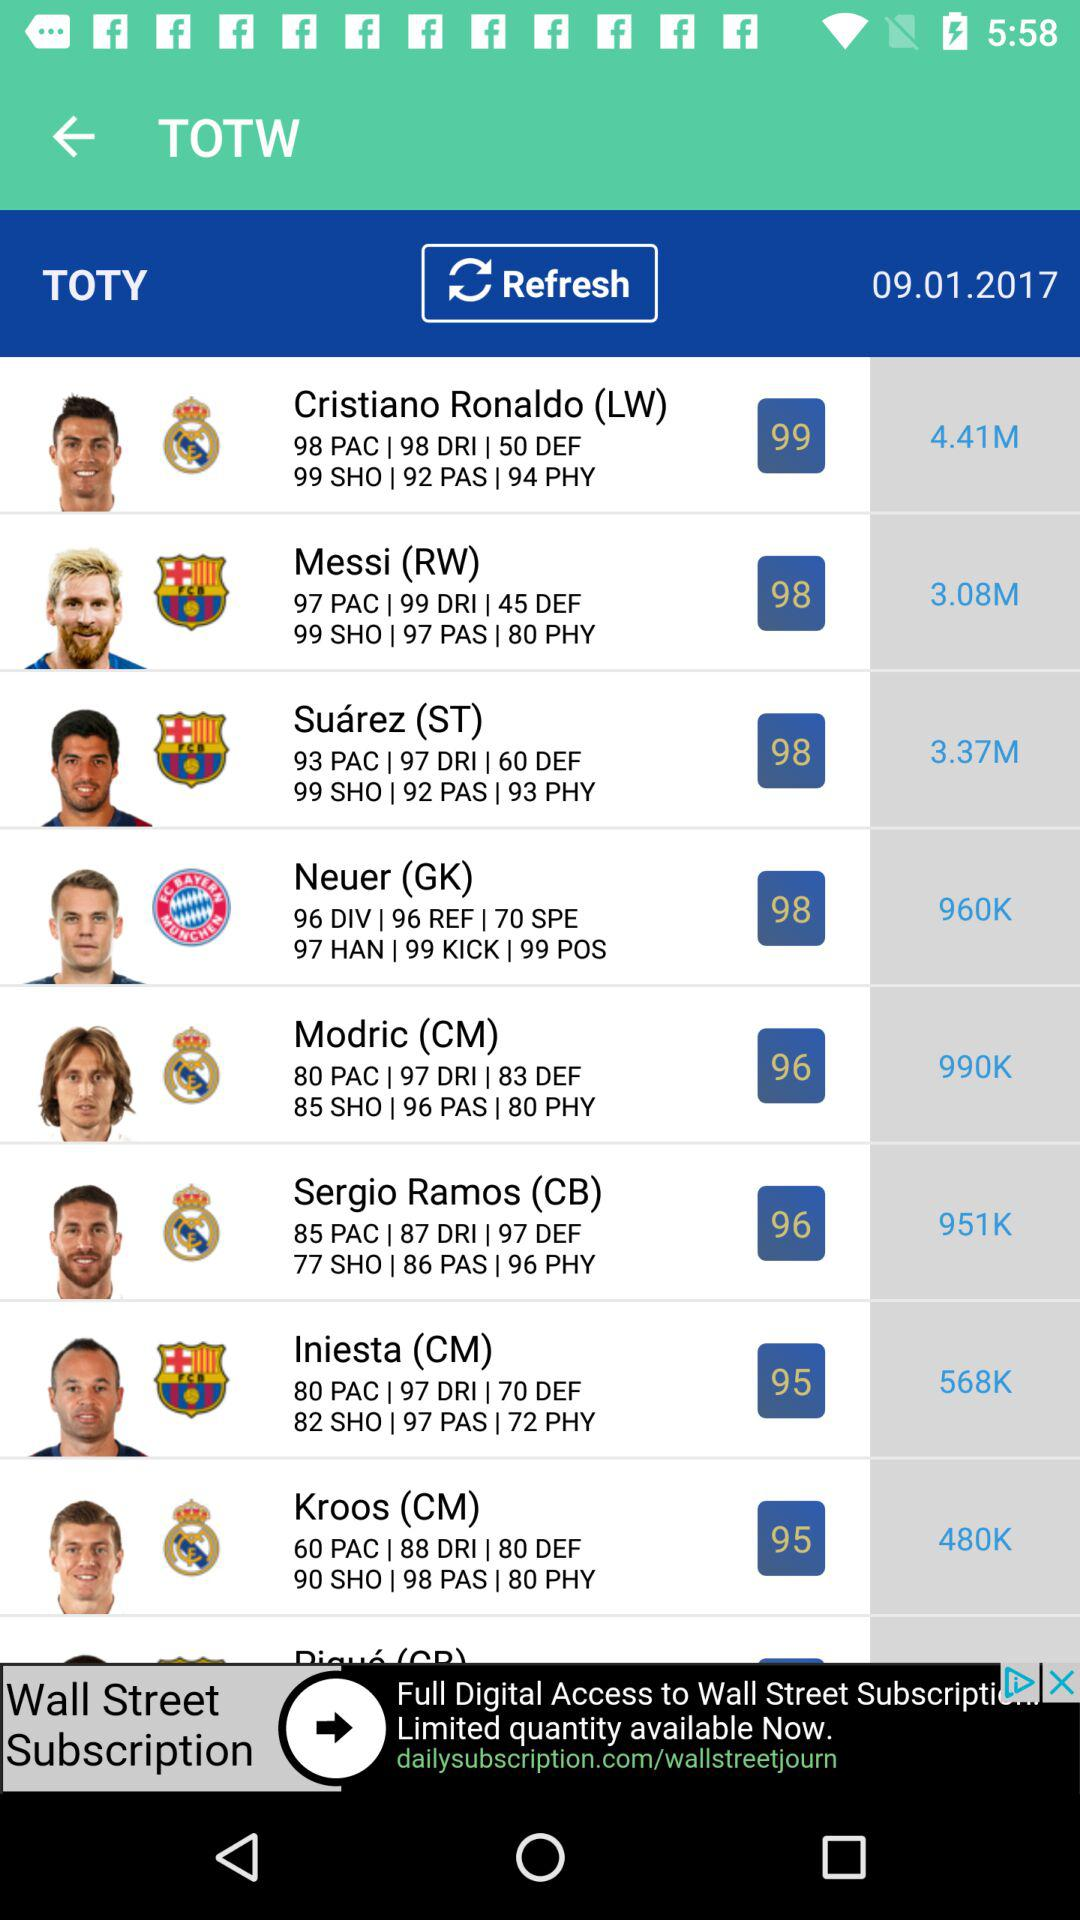What is the PAC of Cristiano Ronaldo? The PAC of Cristiano Ronaldo is 98. 